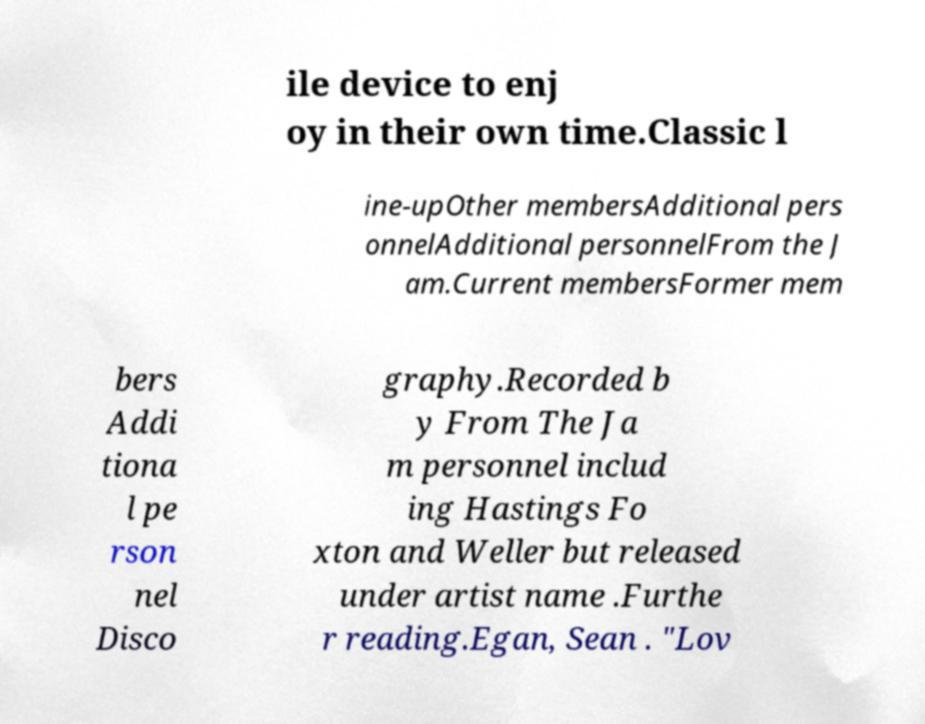Please identify and transcribe the text found in this image. ile device to enj oy in their own time.Classic l ine-upOther membersAdditional pers onnelAdditional personnelFrom the J am.Current membersFormer mem bers Addi tiona l pe rson nel Disco graphy.Recorded b y From The Ja m personnel includ ing Hastings Fo xton and Weller but released under artist name .Furthe r reading.Egan, Sean . "Lov 